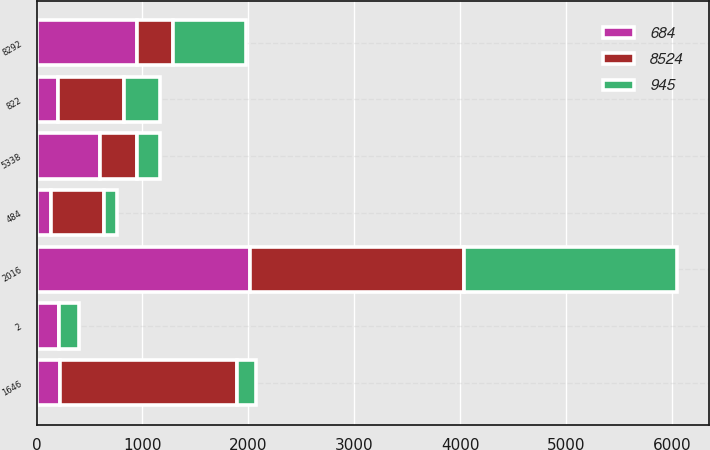Convert chart. <chart><loc_0><loc_0><loc_500><loc_500><stacked_bar_chart><ecel><fcel>2016<fcel>5338<fcel>1646<fcel>822<fcel>484<fcel>2<fcel>8292<nl><fcel>945<fcel>2016<fcel>214<fcel>185<fcel>344<fcel>124<fcel>183<fcel>684<nl><fcel>8524<fcel>2015<fcel>344<fcel>1667<fcel>625<fcel>500<fcel>1<fcel>344<nl><fcel>684<fcel>2015<fcel>603<fcel>221<fcel>201<fcel>135<fcel>215<fcel>945<nl></chart> 